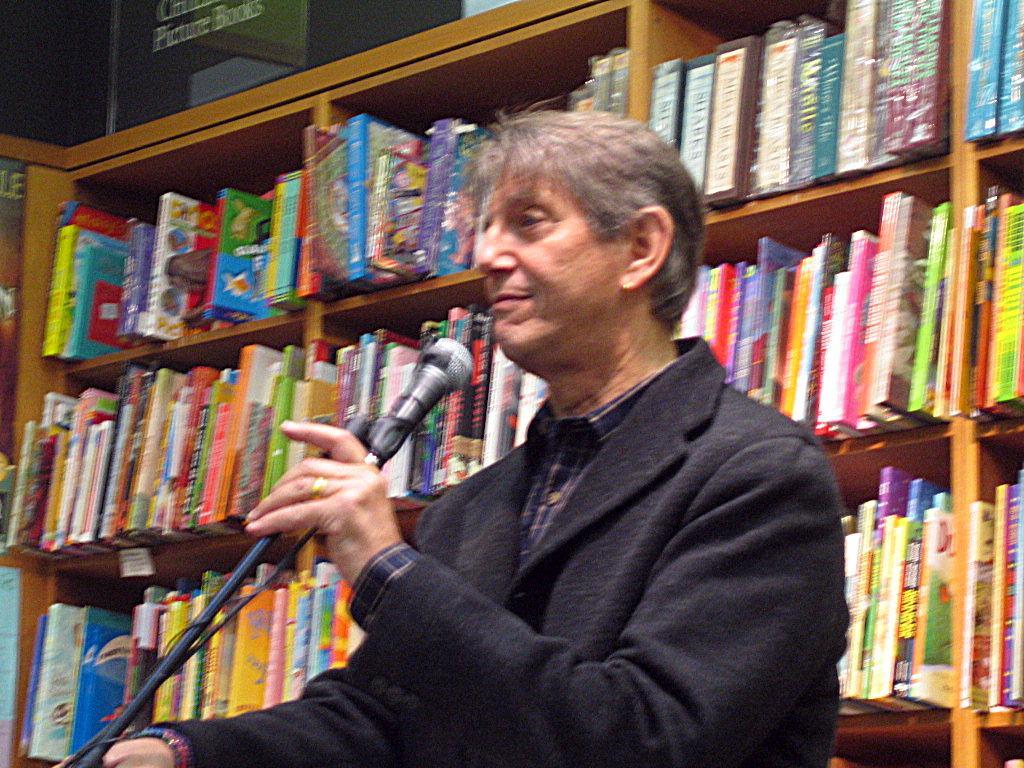Can you describe this image briefly? In this picture I can see a man holding mikes, and in the background there are books in the racks. 